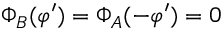Convert formula to latex. <formula><loc_0><loc_0><loc_500><loc_500>\Phi _ { B } ( \varphi ^ { \prime } ) = \Phi _ { A } ( - \varphi ^ { \prime } ) = 0</formula> 